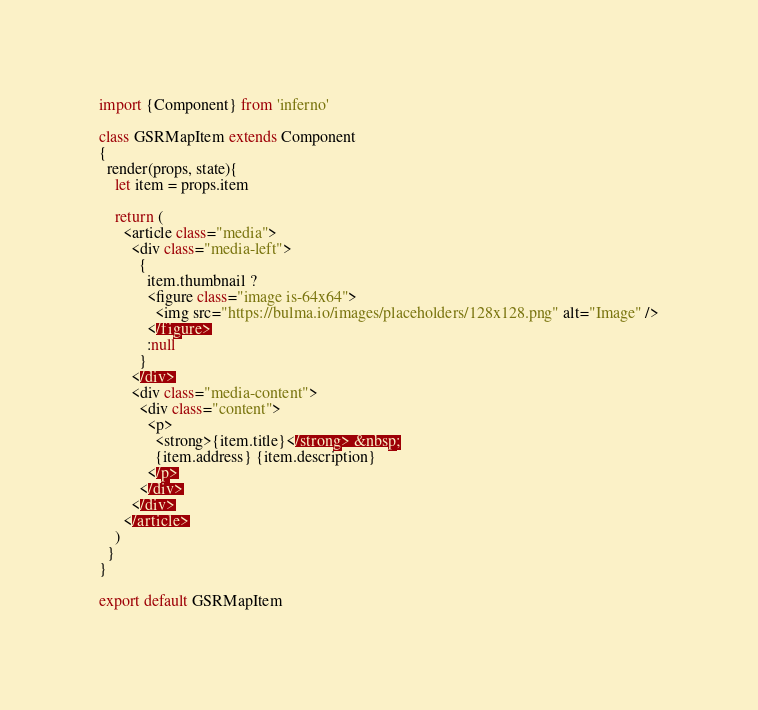Convert code to text. <code><loc_0><loc_0><loc_500><loc_500><_JavaScript_>import {Component} from 'inferno'

class GSRMapItem extends Component
{
  render(props, state){
    let item = props.item

    return (
      <article class="media">
        <div class="media-left">
          {
            item.thumbnail ? 
            <figure class="image is-64x64">
              <img src="https://bulma.io/images/placeholders/128x128.png" alt="Image" />
            </figure>
            :null
          }
        </div>
        <div class="media-content">
          <div class="content">
            <p>
              <strong>{item.title}</strong> &nbsp;
              {item.address} {item.description}
            </p>
          </div>
        </div>
      </article>
    )
  }
}

export default GSRMapItem</code> 